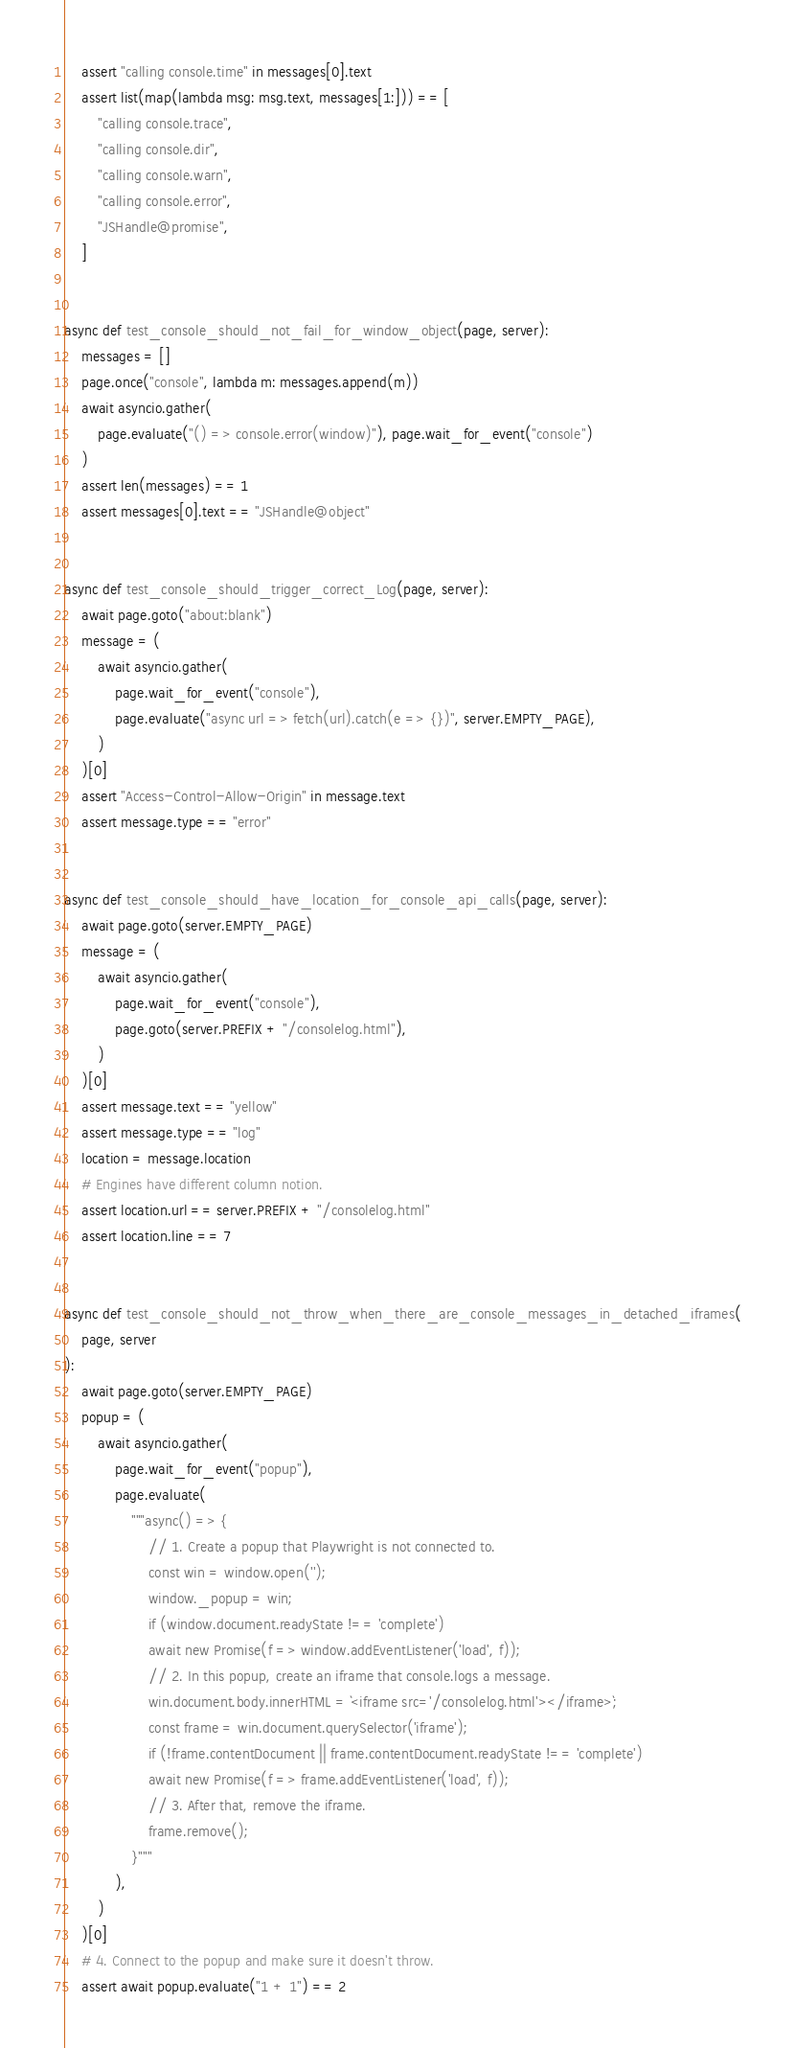Convert code to text. <code><loc_0><loc_0><loc_500><loc_500><_Python_>    assert "calling console.time" in messages[0].text
    assert list(map(lambda msg: msg.text, messages[1:])) == [
        "calling console.trace",
        "calling console.dir",
        "calling console.warn",
        "calling console.error",
        "JSHandle@promise",
    ]


async def test_console_should_not_fail_for_window_object(page, server):
    messages = []
    page.once("console", lambda m: messages.append(m))
    await asyncio.gather(
        page.evaluate("() => console.error(window)"), page.wait_for_event("console")
    )
    assert len(messages) == 1
    assert messages[0].text == "JSHandle@object"


async def test_console_should_trigger_correct_Log(page, server):
    await page.goto("about:blank")
    message = (
        await asyncio.gather(
            page.wait_for_event("console"),
            page.evaluate("async url => fetch(url).catch(e => {})", server.EMPTY_PAGE),
        )
    )[0]
    assert "Access-Control-Allow-Origin" in message.text
    assert message.type == "error"


async def test_console_should_have_location_for_console_api_calls(page, server):
    await page.goto(server.EMPTY_PAGE)
    message = (
        await asyncio.gather(
            page.wait_for_event("console"),
            page.goto(server.PREFIX + "/consolelog.html"),
        )
    )[0]
    assert message.text == "yellow"
    assert message.type == "log"
    location = message.location
    # Engines have different column notion.
    assert location.url == server.PREFIX + "/consolelog.html"
    assert location.line == 7


async def test_console_should_not_throw_when_there_are_console_messages_in_detached_iframes(
    page, server
):
    await page.goto(server.EMPTY_PAGE)
    popup = (
        await asyncio.gather(
            page.wait_for_event("popup"),
            page.evaluate(
                """async() => {
                    // 1. Create a popup that Playwright is not connected to.
                    const win = window.open('');
                    window._popup = win;
                    if (window.document.readyState !== 'complete')
                    await new Promise(f => window.addEventListener('load', f));
                    // 2. In this popup, create an iframe that console.logs a message.
                    win.document.body.innerHTML = `<iframe src='/consolelog.html'></iframe>`;
                    const frame = win.document.querySelector('iframe');
                    if (!frame.contentDocument || frame.contentDocument.readyState !== 'complete')
                    await new Promise(f => frame.addEventListener('load', f));
                    // 3. After that, remove the iframe.
                    frame.remove();
                }"""
            ),
        )
    )[0]
    # 4. Connect to the popup and make sure it doesn't throw.
    assert await popup.evaluate("1 + 1") == 2
</code> 